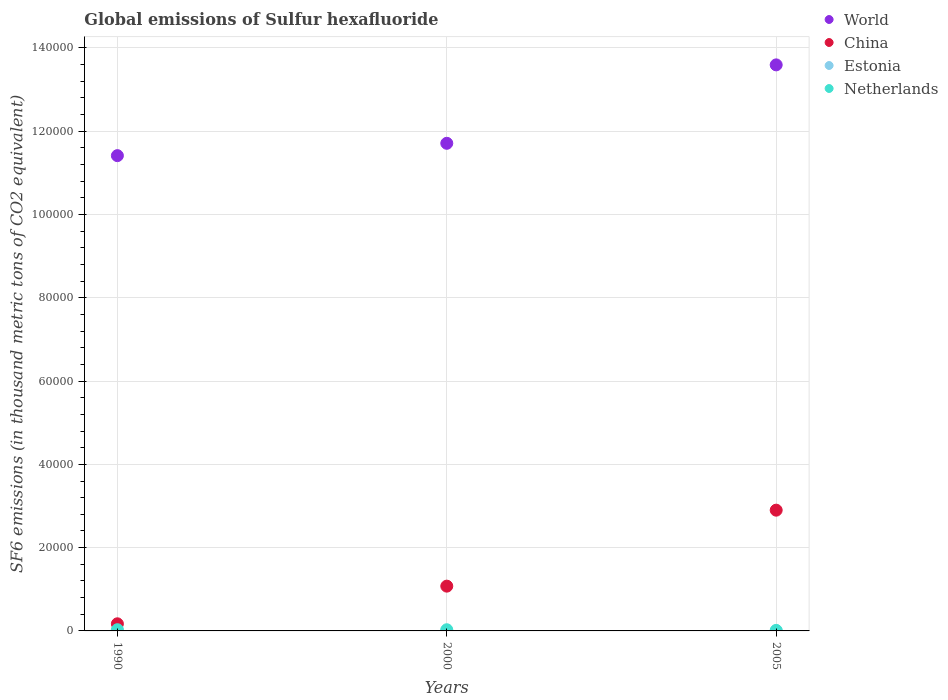Across all years, what is the maximum global emissions of Sulfur hexafluoride in Netherlands?
Make the answer very short. 291.3. Across all years, what is the minimum global emissions of Sulfur hexafluoride in World?
Your answer should be very brief. 1.14e+05. In which year was the global emissions of Sulfur hexafluoride in Netherlands maximum?
Your answer should be compact. 1990. What is the total global emissions of Sulfur hexafluoride in Estonia in the graph?
Your answer should be compact. 5.8. What is the difference between the global emissions of Sulfur hexafluoride in China in 2000 and that in 2005?
Offer a very short reply. -1.82e+04. What is the difference between the global emissions of Sulfur hexafluoride in China in 1990 and the global emissions of Sulfur hexafluoride in Netherlands in 2000?
Provide a short and direct response. 1425.6. What is the average global emissions of Sulfur hexafluoride in World per year?
Provide a short and direct response. 1.22e+05. In the year 1990, what is the difference between the global emissions of Sulfur hexafluoride in China and global emissions of Sulfur hexafluoride in Estonia?
Offer a very short reply. 1707. Is the global emissions of Sulfur hexafluoride in Estonia in 1990 less than that in 2005?
Your response must be concise. Yes. What is the difference between the highest and the second highest global emissions of Sulfur hexafluoride in Estonia?
Your answer should be very brief. 0.2. What is the difference between the highest and the lowest global emissions of Sulfur hexafluoride in World?
Keep it short and to the point. 2.18e+04. Is it the case that in every year, the sum of the global emissions of Sulfur hexafluoride in Estonia and global emissions of Sulfur hexafluoride in China  is greater than the global emissions of Sulfur hexafluoride in World?
Keep it short and to the point. No. Is the global emissions of Sulfur hexafluoride in China strictly greater than the global emissions of Sulfur hexafluoride in Estonia over the years?
Make the answer very short. Yes. How many years are there in the graph?
Ensure brevity in your answer.  3. Does the graph contain any zero values?
Make the answer very short. No. Where does the legend appear in the graph?
Your answer should be very brief. Top right. How are the legend labels stacked?
Keep it short and to the point. Vertical. What is the title of the graph?
Give a very brief answer. Global emissions of Sulfur hexafluoride. What is the label or title of the X-axis?
Give a very brief answer. Years. What is the label or title of the Y-axis?
Provide a short and direct response. SF6 emissions (in thousand metric tons of CO2 equivalent). What is the SF6 emissions (in thousand metric tons of CO2 equivalent) of World in 1990?
Your answer should be very brief. 1.14e+05. What is the SF6 emissions (in thousand metric tons of CO2 equivalent) of China in 1990?
Provide a succinct answer. 1708.6. What is the SF6 emissions (in thousand metric tons of CO2 equivalent) in Estonia in 1990?
Give a very brief answer. 1.6. What is the SF6 emissions (in thousand metric tons of CO2 equivalent) in Netherlands in 1990?
Provide a succinct answer. 291.3. What is the SF6 emissions (in thousand metric tons of CO2 equivalent) in World in 2000?
Ensure brevity in your answer.  1.17e+05. What is the SF6 emissions (in thousand metric tons of CO2 equivalent) in China in 2000?
Provide a short and direct response. 1.08e+04. What is the SF6 emissions (in thousand metric tons of CO2 equivalent) in Estonia in 2000?
Your answer should be compact. 2. What is the SF6 emissions (in thousand metric tons of CO2 equivalent) of Netherlands in 2000?
Your response must be concise. 283. What is the SF6 emissions (in thousand metric tons of CO2 equivalent) of World in 2005?
Ensure brevity in your answer.  1.36e+05. What is the SF6 emissions (in thousand metric tons of CO2 equivalent) in China in 2005?
Ensure brevity in your answer.  2.90e+04. What is the SF6 emissions (in thousand metric tons of CO2 equivalent) of Estonia in 2005?
Offer a very short reply. 2.2. What is the SF6 emissions (in thousand metric tons of CO2 equivalent) in Netherlands in 2005?
Your answer should be compact. 126.9. Across all years, what is the maximum SF6 emissions (in thousand metric tons of CO2 equivalent) in World?
Provide a short and direct response. 1.36e+05. Across all years, what is the maximum SF6 emissions (in thousand metric tons of CO2 equivalent) in China?
Offer a terse response. 2.90e+04. Across all years, what is the maximum SF6 emissions (in thousand metric tons of CO2 equivalent) in Estonia?
Offer a very short reply. 2.2. Across all years, what is the maximum SF6 emissions (in thousand metric tons of CO2 equivalent) of Netherlands?
Provide a short and direct response. 291.3. Across all years, what is the minimum SF6 emissions (in thousand metric tons of CO2 equivalent) in World?
Offer a very short reply. 1.14e+05. Across all years, what is the minimum SF6 emissions (in thousand metric tons of CO2 equivalent) in China?
Ensure brevity in your answer.  1708.6. Across all years, what is the minimum SF6 emissions (in thousand metric tons of CO2 equivalent) of Estonia?
Offer a terse response. 1.6. Across all years, what is the minimum SF6 emissions (in thousand metric tons of CO2 equivalent) of Netherlands?
Offer a terse response. 126.9. What is the total SF6 emissions (in thousand metric tons of CO2 equivalent) of World in the graph?
Your answer should be compact. 3.67e+05. What is the total SF6 emissions (in thousand metric tons of CO2 equivalent) of China in the graph?
Give a very brief answer. 4.15e+04. What is the total SF6 emissions (in thousand metric tons of CO2 equivalent) in Estonia in the graph?
Your answer should be very brief. 5.8. What is the total SF6 emissions (in thousand metric tons of CO2 equivalent) in Netherlands in the graph?
Your answer should be compact. 701.2. What is the difference between the SF6 emissions (in thousand metric tons of CO2 equivalent) of World in 1990 and that in 2000?
Ensure brevity in your answer.  -2964.6. What is the difference between the SF6 emissions (in thousand metric tons of CO2 equivalent) in China in 1990 and that in 2000?
Offer a terse response. -9045. What is the difference between the SF6 emissions (in thousand metric tons of CO2 equivalent) of Estonia in 1990 and that in 2000?
Make the answer very short. -0.4. What is the difference between the SF6 emissions (in thousand metric tons of CO2 equivalent) in Netherlands in 1990 and that in 2000?
Give a very brief answer. 8.3. What is the difference between the SF6 emissions (in thousand metric tons of CO2 equivalent) of World in 1990 and that in 2005?
Make the answer very short. -2.18e+04. What is the difference between the SF6 emissions (in thousand metric tons of CO2 equivalent) of China in 1990 and that in 2005?
Your response must be concise. -2.73e+04. What is the difference between the SF6 emissions (in thousand metric tons of CO2 equivalent) of Estonia in 1990 and that in 2005?
Your response must be concise. -0.6. What is the difference between the SF6 emissions (in thousand metric tons of CO2 equivalent) in Netherlands in 1990 and that in 2005?
Your answer should be compact. 164.4. What is the difference between the SF6 emissions (in thousand metric tons of CO2 equivalent) in World in 2000 and that in 2005?
Ensure brevity in your answer.  -1.88e+04. What is the difference between the SF6 emissions (in thousand metric tons of CO2 equivalent) of China in 2000 and that in 2005?
Your answer should be very brief. -1.82e+04. What is the difference between the SF6 emissions (in thousand metric tons of CO2 equivalent) in Estonia in 2000 and that in 2005?
Provide a succinct answer. -0.2. What is the difference between the SF6 emissions (in thousand metric tons of CO2 equivalent) of Netherlands in 2000 and that in 2005?
Offer a terse response. 156.1. What is the difference between the SF6 emissions (in thousand metric tons of CO2 equivalent) in World in 1990 and the SF6 emissions (in thousand metric tons of CO2 equivalent) in China in 2000?
Give a very brief answer. 1.03e+05. What is the difference between the SF6 emissions (in thousand metric tons of CO2 equivalent) in World in 1990 and the SF6 emissions (in thousand metric tons of CO2 equivalent) in Estonia in 2000?
Provide a succinct answer. 1.14e+05. What is the difference between the SF6 emissions (in thousand metric tons of CO2 equivalent) in World in 1990 and the SF6 emissions (in thousand metric tons of CO2 equivalent) in Netherlands in 2000?
Your answer should be compact. 1.14e+05. What is the difference between the SF6 emissions (in thousand metric tons of CO2 equivalent) of China in 1990 and the SF6 emissions (in thousand metric tons of CO2 equivalent) of Estonia in 2000?
Your answer should be compact. 1706.6. What is the difference between the SF6 emissions (in thousand metric tons of CO2 equivalent) of China in 1990 and the SF6 emissions (in thousand metric tons of CO2 equivalent) of Netherlands in 2000?
Offer a terse response. 1425.6. What is the difference between the SF6 emissions (in thousand metric tons of CO2 equivalent) in Estonia in 1990 and the SF6 emissions (in thousand metric tons of CO2 equivalent) in Netherlands in 2000?
Provide a succinct answer. -281.4. What is the difference between the SF6 emissions (in thousand metric tons of CO2 equivalent) in World in 1990 and the SF6 emissions (in thousand metric tons of CO2 equivalent) in China in 2005?
Keep it short and to the point. 8.51e+04. What is the difference between the SF6 emissions (in thousand metric tons of CO2 equivalent) of World in 1990 and the SF6 emissions (in thousand metric tons of CO2 equivalent) of Estonia in 2005?
Keep it short and to the point. 1.14e+05. What is the difference between the SF6 emissions (in thousand metric tons of CO2 equivalent) in World in 1990 and the SF6 emissions (in thousand metric tons of CO2 equivalent) in Netherlands in 2005?
Your answer should be compact. 1.14e+05. What is the difference between the SF6 emissions (in thousand metric tons of CO2 equivalent) of China in 1990 and the SF6 emissions (in thousand metric tons of CO2 equivalent) of Estonia in 2005?
Keep it short and to the point. 1706.4. What is the difference between the SF6 emissions (in thousand metric tons of CO2 equivalent) of China in 1990 and the SF6 emissions (in thousand metric tons of CO2 equivalent) of Netherlands in 2005?
Give a very brief answer. 1581.7. What is the difference between the SF6 emissions (in thousand metric tons of CO2 equivalent) of Estonia in 1990 and the SF6 emissions (in thousand metric tons of CO2 equivalent) of Netherlands in 2005?
Make the answer very short. -125.3. What is the difference between the SF6 emissions (in thousand metric tons of CO2 equivalent) in World in 2000 and the SF6 emissions (in thousand metric tons of CO2 equivalent) in China in 2005?
Offer a terse response. 8.81e+04. What is the difference between the SF6 emissions (in thousand metric tons of CO2 equivalent) of World in 2000 and the SF6 emissions (in thousand metric tons of CO2 equivalent) of Estonia in 2005?
Your answer should be very brief. 1.17e+05. What is the difference between the SF6 emissions (in thousand metric tons of CO2 equivalent) in World in 2000 and the SF6 emissions (in thousand metric tons of CO2 equivalent) in Netherlands in 2005?
Your answer should be very brief. 1.17e+05. What is the difference between the SF6 emissions (in thousand metric tons of CO2 equivalent) of China in 2000 and the SF6 emissions (in thousand metric tons of CO2 equivalent) of Estonia in 2005?
Offer a terse response. 1.08e+04. What is the difference between the SF6 emissions (in thousand metric tons of CO2 equivalent) of China in 2000 and the SF6 emissions (in thousand metric tons of CO2 equivalent) of Netherlands in 2005?
Make the answer very short. 1.06e+04. What is the difference between the SF6 emissions (in thousand metric tons of CO2 equivalent) in Estonia in 2000 and the SF6 emissions (in thousand metric tons of CO2 equivalent) in Netherlands in 2005?
Make the answer very short. -124.9. What is the average SF6 emissions (in thousand metric tons of CO2 equivalent) in World per year?
Keep it short and to the point. 1.22e+05. What is the average SF6 emissions (in thousand metric tons of CO2 equivalent) of China per year?
Make the answer very short. 1.38e+04. What is the average SF6 emissions (in thousand metric tons of CO2 equivalent) of Estonia per year?
Your answer should be compact. 1.93. What is the average SF6 emissions (in thousand metric tons of CO2 equivalent) in Netherlands per year?
Ensure brevity in your answer.  233.73. In the year 1990, what is the difference between the SF6 emissions (in thousand metric tons of CO2 equivalent) in World and SF6 emissions (in thousand metric tons of CO2 equivalent) in China?
Keep it short and to the point. 1.12e+05. In the year 1990, what is the difference between the SF6 emissions (in thousand metric tons of CO2 equivalent) of World and SF6 emissions (in thousand metric tons of CO2 equivalent) of Estonia?
Your answer should be compact. 1.14e+05. In the year 1990, what is the difference between the SF6 emissions (in thousand metric tons of CO2 equivalent) of World and SF6 emissions (in thousand metric tons of CO2 equivalent) of Netherlands?
Your response must be concise. 1.14e+05. In the year 1990, what is the difference between the SF6 emissions (in thousand metric tons of CO2 equivalent) in China and SF6 emissions (in thousand metric tons of CO2 equivalent) in Estonia?
Offer a very short reply. 1707. In the year 1990, what is the difference between the SF6 emissions (in thousand metric tons of CO2 equivalent) in China and SF6 emissions (in thousand metric tons of CO2 equivalent) in Netherlands?
Make the answer very short. 1417.3. In the year 1990, what is the difference between the SF6 emissions (in thousand metric tons of CO2 equivalent) in Estonia and SF6 emissions (in thousand metric tons of CO2 equivalent) in Netherlands?
Offer a very short reply. -289.7. In the year 2000, what is the difference between the SF6 emissions (in thousand metric tons of CO2 equivalent) of World and SF6 emissions (in thousand metric tons of CO2 equivalent) of China?
Give a very brief answer. 1.06e+05. In the year 2000, what is the difference between the SF6 emissions (in thousand metric tons of CO2 equivalent) in World and SF6 emissions (in thousand metric tons of CO2 equivalent) in Estonia?
Keep it short and to the point. 1.17e+05. In the year 2000, what is the difference between the SF6 emissions (in thousand metric tons of CO2 equivalent) of World and SF6 emissions (in thousand metric tons of CO2 equivalent) of Netherlands?
Offer a terse response. 1.17e+05. In the year 2000, what is the difference between the SF6 emissions (in thousand metric tons of CO2 equivalent) of China and SF6 emissions (in thousand metric tons of CO2 equivalent) of Estonia?
Your response must be concise. 1.08e+04. In the year 2000, what is the difference between the SF6 emissions (in thousand metric tons of CO2 equivalent) in China and SF6 emissions (in thousand metric tons of CO2 equivalent) in Netherlands?
Your answer should be very brief. 1.05e+04. In the year 2000, what is the difference between the SF6 emissions (in thousand metric tons of CO2 equivalent) of Estonia and SF6 emissions (in thousand metric tons of CO2 equivalent) of Netherlands?
Ensure brevity in your answer.  -281. In the year 2005, what is the difference between the SF6 emissions (in thousand metric tons of CO2 equivalent) of World and SF6 emissions (in thousand metric tons of CO2 equivalent) of China?
Your response must be concise. 1.07e+05. In the year 2005, what is the difference between the SF6 emissions (in thousand metric tons of CO2 equivalent) of World and SF6 emissions (in thousand metric tons of CO2 equivalent) of Estonia?
Your response must be concise. 1.36e+05. In the year 2005, what is the difference between the SF6 emissions (in thousand metric tons of CO2 equivalent) in World and SF6 emissions (in thousand metric tons of CO2 equivalent) in Netherlands?
Your answer should be compact. 1.36e+05. In the year 2005, what is the difference between the SF6 emissions (in thousand metric tons of CO2 equivalent) in China and SF6 emissions (in thousand metric tons of CO2 equivalent) in Estonia?
Your response must be concise. 2.90e+04. In the year 2005, what is the difference between the SF6 emissions (in thousand metric tons of CO2 equivalent) of China and SF6 emissions (in thousand metric tons of CO2 equivalent) of Netherlands?
Provide a succinct answer. 2.89e+04. In the year 2005, what is the difference between the SF6 emissions (in thousand metric tons of CO2 equivalent) of Estonia and SF6 emissions (in thousand metric tons of CO2 equivalent) of Netherlands?
Offer a terse response. -124.7. What is the ratio of the SF6 emissions (in thousand metric tons of CO2 equivalent) of World in 1990 to that in 2000?
Offer a terse response. 0.97. What is the ratio of the SF6 emissions (in thousand metric tons of CO2 equivalent) of China in 1990 to that in 2000?
Provide a short and direct response. 0.16. What is the ratio of the SF6 emissions (in thousand metric tons of CO2 equivalent) of Netherlands in 1990 to that in 2000?
Provide a succinct answer. 1.03. What is the ratio of the SF6 emissions (in thousand metric tons of CO2 equivalent) in World in 1990 to that in 2005?
Offer a terse response. 0.84. What is the ratio of the SF6 emissions (in thousand metric tons of CO2 equivalent) in China in 1990 to that in 2005?
Provide a short and direct response. 0.06. What is the ratio of the SF6 emissions (in thousand metric tons of CO2 equivalent) in Estonia in 1990 to that in 2005?
Your answer should be compact. 0.73. What is the ratio of the SF6 emissions (in thousand metric tons of CO2 equivalent) in Netherlands in 1990 to that in 2005?
Offer a very short reply. 2.3. What is the ratio of the SF6 emissions (in thousand metric tons of CO2 equivalent) of World in 2000 to that in 2005?
Offer a very short reply. 0.86. What is the ratio of the SF6 emissions (in thousand metric tons of CO2 equivalent) of China in 2000 to that in 2005?
Your answer should be compact. 0.37. What is the ratio of the SF6 emissions (in thousand metric tons of CO2 equivalent) of Netherlands in 2000 to that in 2005?
Your answer should be very brief. 2.23. What is the difference between the highest and the second highest SF6 emissions (in thousand metric tons of CO2 equivalent) of World?
Give a very brief answer. 1.88e+04. What is the difference between the highest and the second highest SF6 emissions (in thousand metric tons of CO2 equivalent) in China?
Your response must be concise. 1.82e+04. What is the difference between the highest and the second highest SF6 emissions (in thousand metric tons of CO2 equivalent) of Estonia?
Ensure brevity in your answer.  0.2. What is the difference between the highest and the lowest SF6 emissions (in thousand metric tons of CO2 equivalent) in World?
Make the answer very short. 2.18e+04. What is the difference between the highest and the lowest SF6 emissions (in thousand metric tons of CO2 equivalent) of China?
Provide a short and direct response. 2.73e+04. What is the difference between the highest and the lowest SF6 emissions (in thousand metric tons of CO2 equivalent) in Netherlands?
Ensure brevity in your answer.  164.4. 